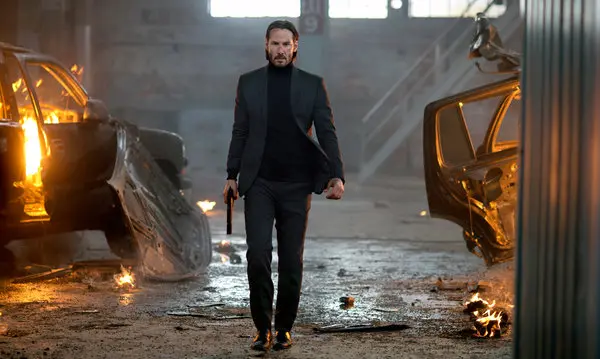Can you describe the character's emotions and what might be motivating him? The character's expression is one of intense determination and focus. His stride is confident and purposeful, suggesting that he is on a mission. The serious look on his face, coupled with the firm grip on his gun, indicates that he is ready for confrontation and is likely driven by a powerful motivation, possibly revenge or a desperate need to achieve a crucial objective. The dangerous and chaotic surroundings only add to the urgency of his actions. Why do you think there are burning cars around him? The burning cars around the character suggest a recent or ongoing battle. This could be the result of a high-stakes chase, a violent confrontation, or a deliberate act of destruction to eliminate obstacles or threats. The presence of such destruction underscores the perilous environment the character is navigating, highlighting the danger and intensity of the situation. These burning cars serve to elevate the dramatic tension of the scene, emphasizing the character's resolve amid chaos. Imagine the most imaginative scenario you can think of for this scene. Go wild! In this highly imaginative scenario, the man is actually a time-traveling agent sent to prevent a catastrophic event. The burning cars are not mere vehicles but are actually remnants of a future dystopian world where rebel machines wage war against humanity. Each flame is fueled by a self-repairing nanotechnology, and the debris around is a mix of advanced robotics and alien tech. The man’s mission is to retrieve a stolen artifact from the future, hidden in the warehouse, that has the power to either destroy or save the human race. As he walks with unwavering determination, he knows that a hidden enemy—capable of invisibility and mind control—is lurking nearby, ready to stop him at all costs. 